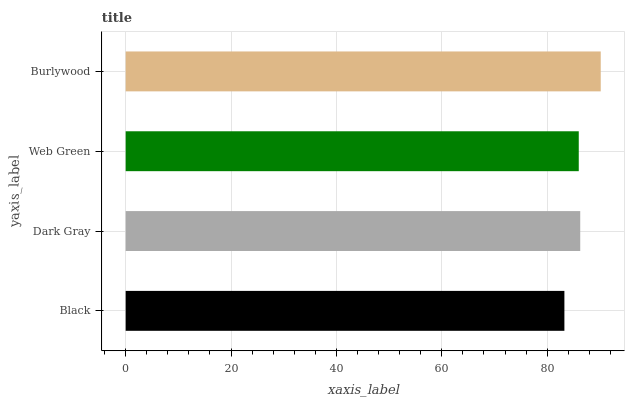Is Black the minimum?
Answer yes or no. Yes. Is Burlywood the maximum?
Answer yes or no. Yes. Is Dark Gray the minimum?
Answer yes or no. No. Is Dark Gray the maximum?
Answer yes or no. No. Is Dark Gray greater than Black?
Answer yes or no. Yes. Is Black less than Dark Gray?
Answer yes or no. Yes. Is Black greater than Dark Gray?
Answer yes or no. No. Is Dark Gray less than Black?
Answer yes or no. No. Is Dark Gray the high median?
Answer yes or no. Yes. Is Web Green the low median?
Answer yes or no. Yes. Is Web Green the high median?
Answer yes or no. No. Is Burlywood the low median?
Answer yes or no. No. 